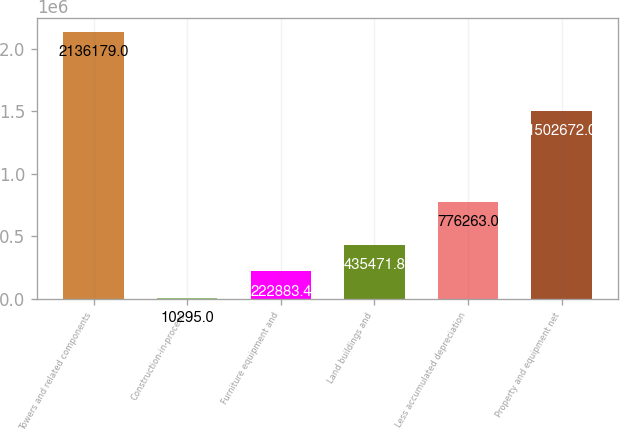Convert chart. <chart><loc_0><loc_0><loc_500><loc_500><bar_chart><fcel>Towers and related components<fcel>Construction-in-process<fcel>Furniture equipment and<fcel>Land buildings and<fcel>Less accumulated depreciation<fcel>Property and equipment net<nl><fcel>2.13618e+06<fcel>10295<fcel>222883<fcel>435472<fcel>776263<fcel>1.50267e+06<nl></chart> 